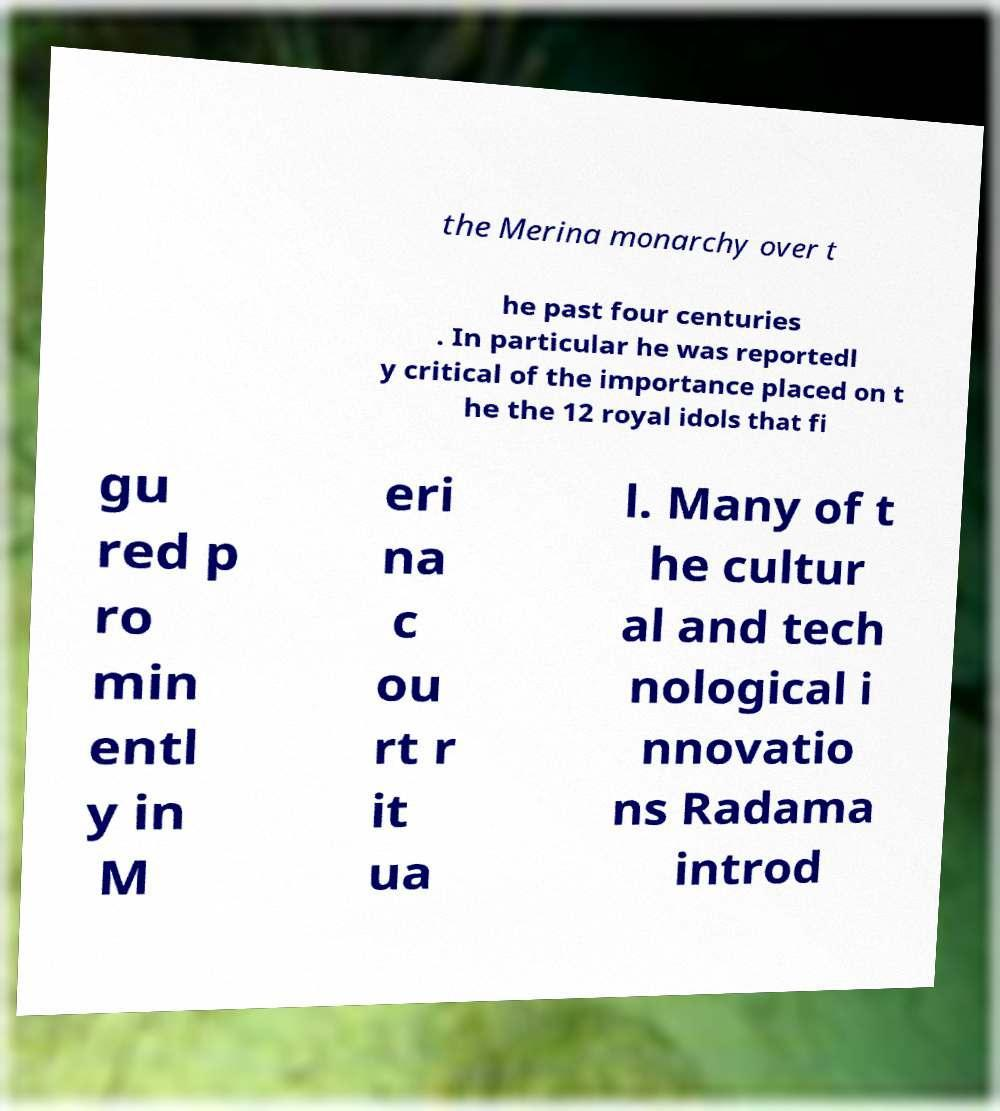Could you assist in decoding the text presented in this image and type it out clearly? the Merina monarchy over t he past four centuries . In particular he was reportedl y critical of the importance placed on t he the 12 royal idols that fi gu red p ro min entl y in M eri na c ou rt r it ua l. Many of t he cultur al and tech nological i nnovatio ns Radama introd 